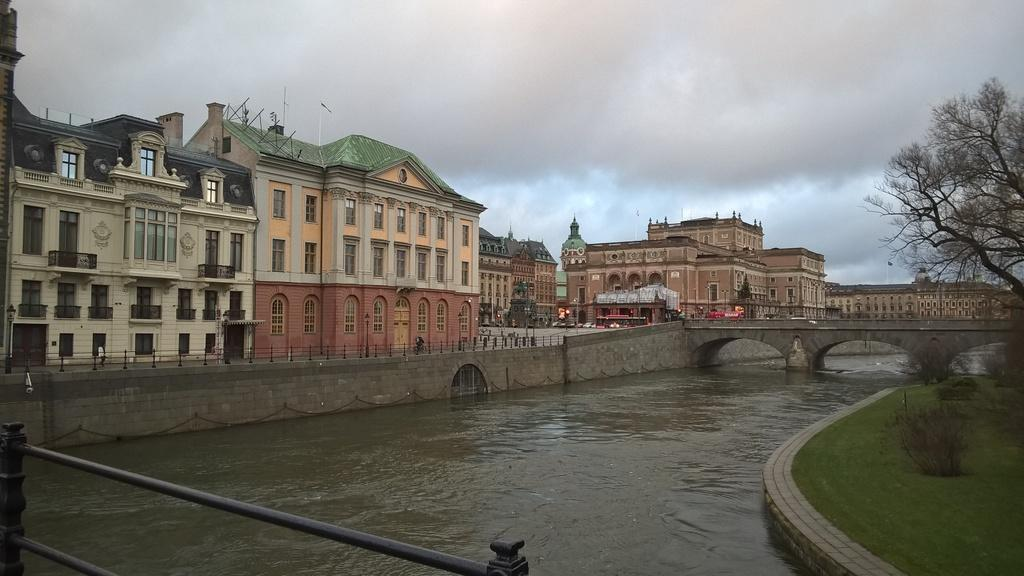What is one of the natural elements present in the image? There is water in the image. What type of vegetation can be seen in the image? There is grass and plants in the image. What structure is present in the image? There is a fence in the image. How many fences can be seen in the image? There is one fence in the image and another in the background. What is the condition of the tree in the image? There is a dried tree in the image. What can be seen in the background of the image? There are buildings, a fence, and the sky visible in the background of the image. What is the weather like in the image? The sky is visible with clouds, suggesting a partly cloudy day. How many pickles are hanging from the fence in the image? There are no pickles present in the image; it features a dried tree and other natural elements. What type of debt is being discussed in the image? There is no mention of debt or any financial topic in the image. 